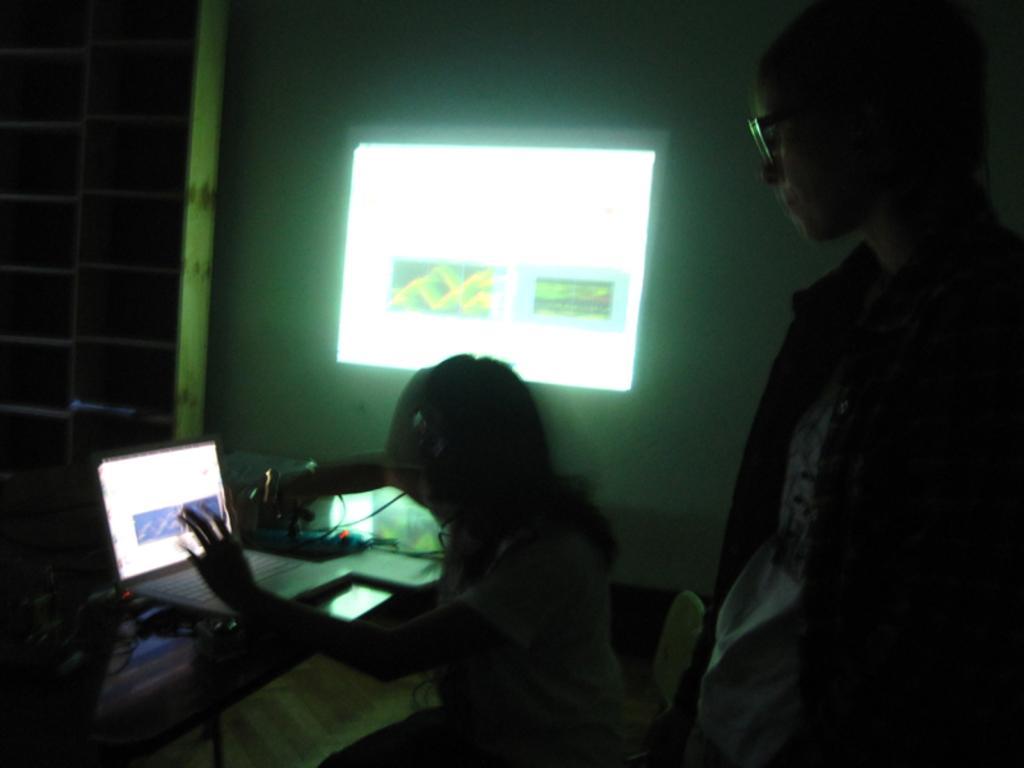Can you describe this image briefly? In this image, we can see people and one of them is wearing glasses and the other is sitting on the chair. In the background, we can see a laptop and some other objects on the table and there is a screen on the wall and we can see a wall. 